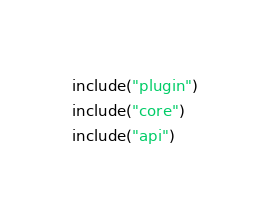<code> <loc_0><loc_0><loc_500><loc_500><_Kotlin_>include("plugin")
include("core")
include("api")</code> 